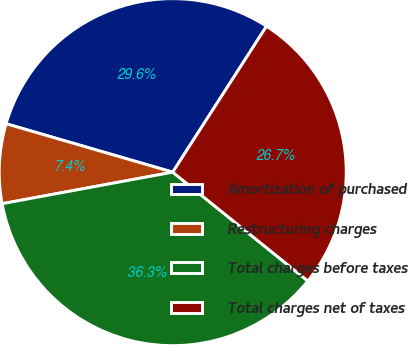Convert chart to OTSL. <chart><loc_0><loc_0><loc_500><loc_500><pie_chart><fcel>Amortization of purchased<fcel>Restructuring charges<fcel>Total charges before taxes<fcel>Total charges net of taxes<nl><fcel>29.59%<fcel>7.41%<fcel>36.3%<fcel>26.7%<nl></chart> 